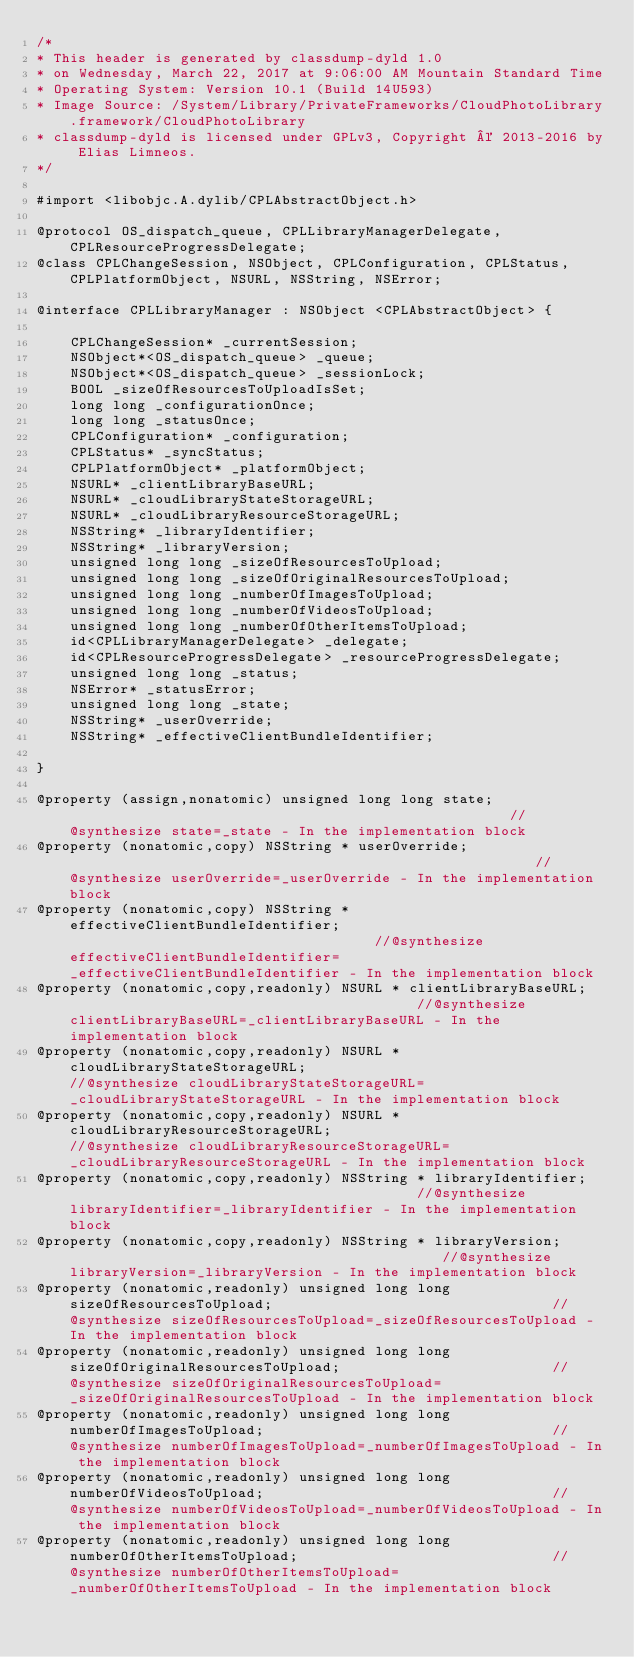Convert code to text. <code><loc_0><loc_0><loc_500><loc_500><_C_>/*
* This header is generated by classdump-dyld 1.0
* on Wednesday, March 22, 2017 at 9:06:00 AM Mountain Standard Time
* Operating System: Version 10.1 (Build 14U593)
* Image Source: /System/Library/PrivateFrameworks/CloudPhotoLibrary.framework/CloudPhotoLibrary
* classdump-dyld is licensed under GPLv3, Copyright © 2013-2016 by Elias Limneos.
*/

#import <libobjc.A.dylib/CPLAbstractObject.h>

@protocol OS_dispatch_queue, CPLLibraryManagerDelegate, CPLResourceProgressDelegate;
@class CPLChangeSession, NSObject, CPLConfiguration, CPLStatus, CPLPlatformObject, NSURL, NSString, NSError;

@interface CPLLibraryManager : NSObject <CPLAbstractObject> {

	CPLChangeSession* _currentSession;
	NSObject*<OS_dispatch_queue> _queue;
	NSObject*<OS_dispatch_queue> _sessionLock;
	BOOL _sizeOfResourcesToUploadIsSet;
	long long _configurationOnce;
	long long _statusOnce;
	CPLConfiguration* _configuration;
	CPLStatus* _syncStatus;
	CPLPlatformObject* _platformObject;
	NSURL* _clientLibraryBaseURL;
	NSURL* _cloudLibraryStateStorageURL;
	NSURL* _cloudLibraryResourceStorageURL;
	NSString* _libraryIdentifier;
	NSString* _libraryVersion;
	unsigned long long _sizeOfResourcesToUpload;
	unsigned long long _sizeOfOriginalResourcesToUpload;
	unsigned long long _numberOfImagesToUpload;
	unsigned long long _numberOfVideosToUpload;
	unsigned long long _numberOfOtherItemsToUpload;
	id<CPLLibraryManagerDelegate> _delegate;
	id<CPLResourceProgressDelegate> _resourceProgressDelegate;
	unsigned long long _status;
	NSError* _statusError;
	unsigned long long _state;
	NSString* _userOverride;
	NSString* _effectiveClientBundleIdentifier;

}

@property (assign,nonatomic) unsigned long long state;                                                     //@synthesize state=_state - In the implementation block
@property (nonatomic,copy) NSString * userOverride;                                                        //@synthesize userOverride=_userOverride - In the implementation block
@property (nonatomic,copy) NSString * effectiveClientBundleIdentifier;                                     //@synthesize effectiveClientBundleIdentifier=_effectiveClientBundleIdentifier - In the implementation block
@property (nonatomic,copy,readonly) NSURL * clientLibraryBaseURL;                                          //@synthesize clientLibraryBaseURL=_clientLibraryBaseURL - In the implementation block
@property (nonatomic,copy,readonly) NSURL * cloudLibraryStateStorageURL;                                   //@synthesize cloudLibraryStateStorageURL=_cloudLibraryStateStorageURL - In the implementation block
@property (nonatomic,copy,readonly) NSURL * cloudLibraryResourceStorageURL;                                //@synthesize cloudLibraryResourceStorageURL=_cloudLibraryResourceStorageURL - In the implementation block
@property (nonatomic,copy,readonly) NSString * libraryIdentifier;                                          //@synthesize libraryIdentifier=_libraryIdentifier - In the implementation block
@property (nonatomic,copy,readonly) NSString * libraryVersion;                                             //@synthesize libraryVersion=_libraryVersion - In the implementation block
@property (nonatomic,readonly) unsigned long long sizeOfResourcesToUpload;                                 //@synthesize sizeOfResourcesToUpload=_sizeOfResourcesToUpload - In the implementation block
@property (nonatomic,readonly) unsigned long long sizeOfOriginalResourcesToUpload;                         //@synthesize sizeOfOriginalResourcesToUpload=_sizeOfOriginalResourcesToUpload - In the implementation block
@property (nonatomic,readonly) unsigned long long numberOfImagesToUpload;                                  //@synthesize numberOfImagesToUpload=_numberOfImagesToUpload - In the implementation block
@property (nonatomic,readonly) unsigned long long numberOfVideosToUpload;                                  //@synthesize numberOfVideosToUpload=_numberOfVideosToUpload - In the implementation block
@property (nonatomic,readonly) unsigned long long numberOfOtherItemsToUpload;                              //@synthesize numberOfOtherItemsToUpload=_numberOfOtherItemsToUpload - In the implementation block</code> 